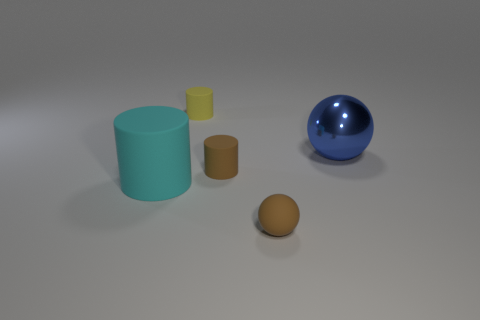Subtract 1 cylinders. How many cylinders are left? 2 Add 4 blue things. How many objects exist? 9 Subtract all spheres. How many objects are left? 3 Add 4 cyan objects. How many cyan objects exist? 5 Subtract 0 brown blocks. How many objects are left? 5 Subtract all yellow rubber things. Subtract all small cyan matte cylinders. How many objects are left? 4 Add 3 tiny brown cylinders. How many tiny brown cylinders are left? 4 